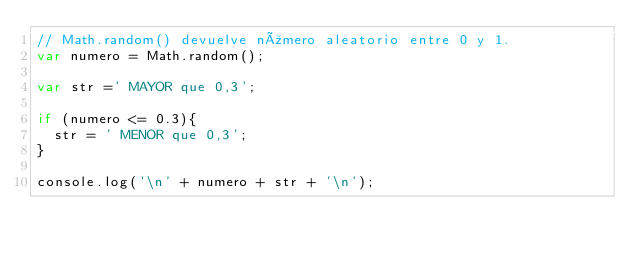Convert code to text. <code><loc_0><loc_0><loc_500><loc_500><_JavaScript_>// Math.random() devuelve número aleatorio entre 0 y 1.
var numero = Math.random();

var str =' MAYOR que 0,3';

if (numero <= 0.3){
  str = ' MENOR que 0,3';
}

console.log('\n' + numero + str + '\n');
</code> 